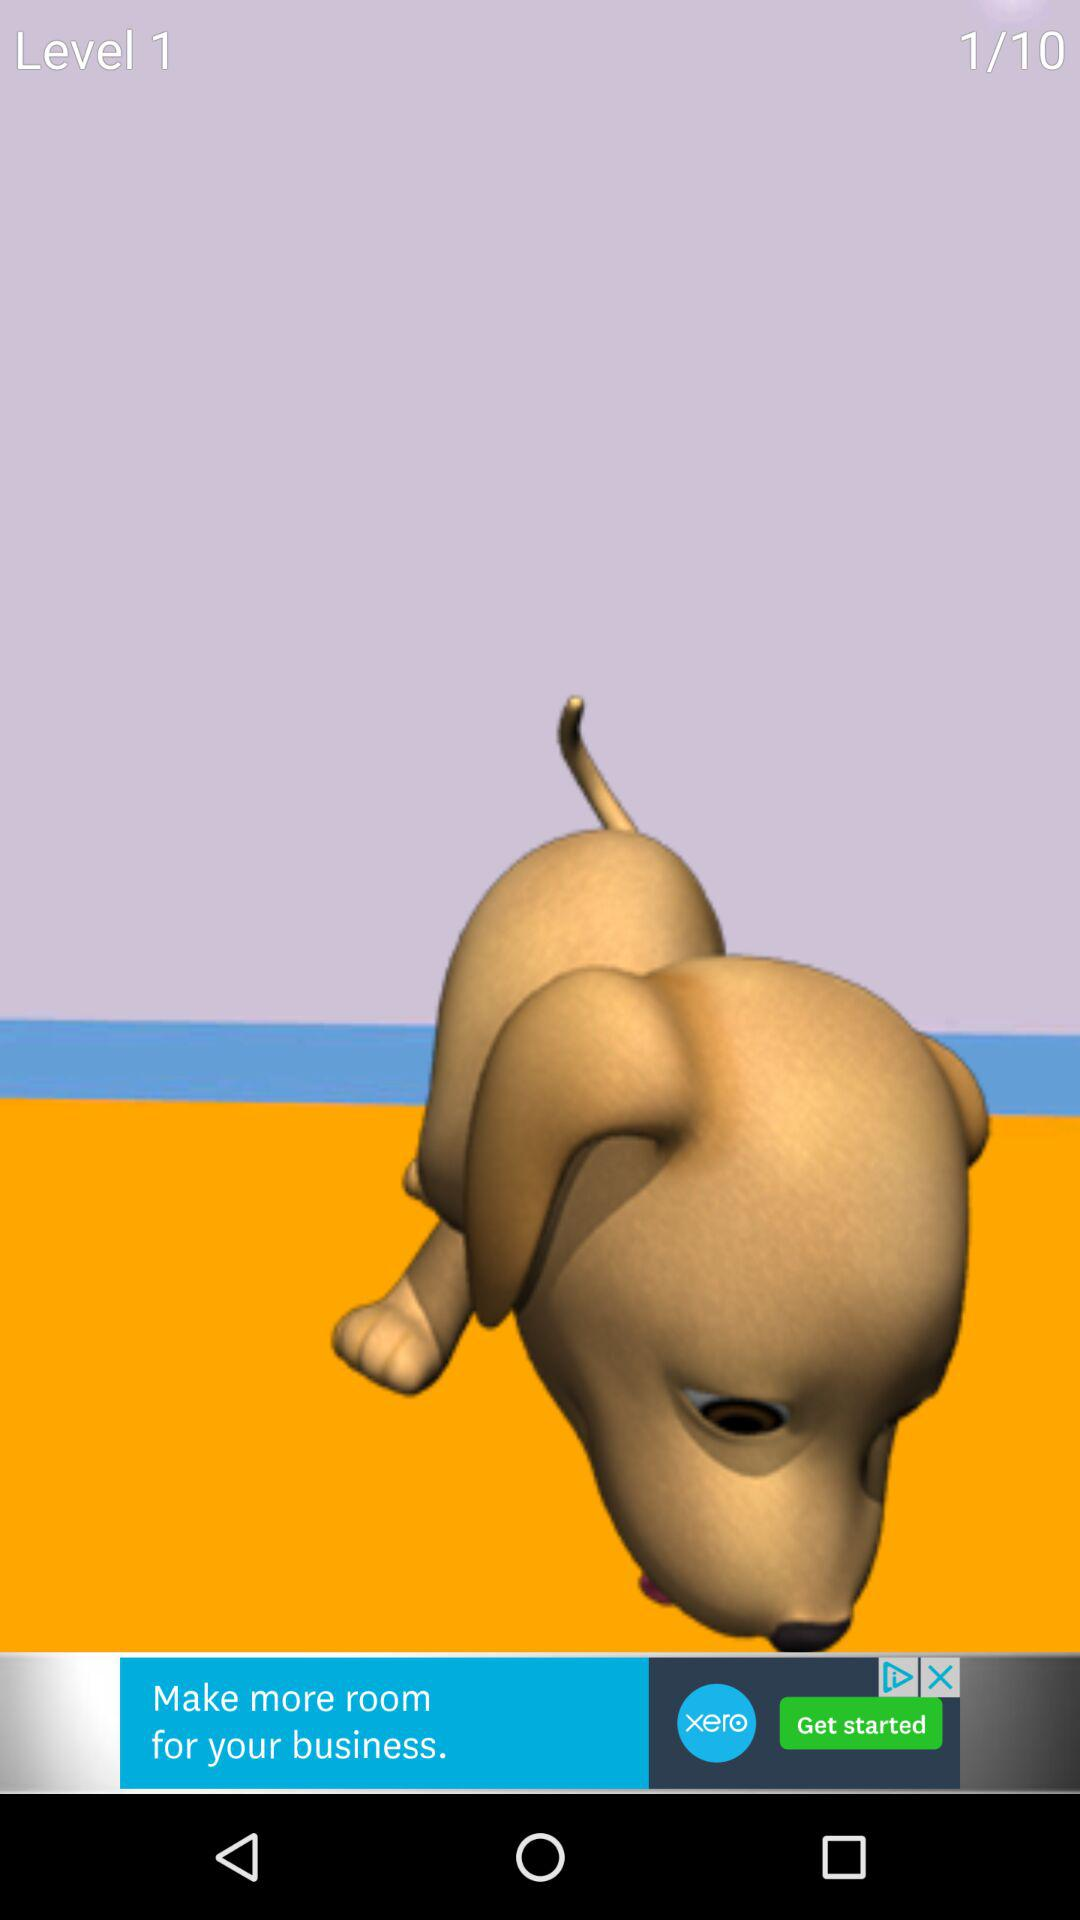What is the name of the application?
When the provided information is insufficient, respond with <no answer>. <no answer> 